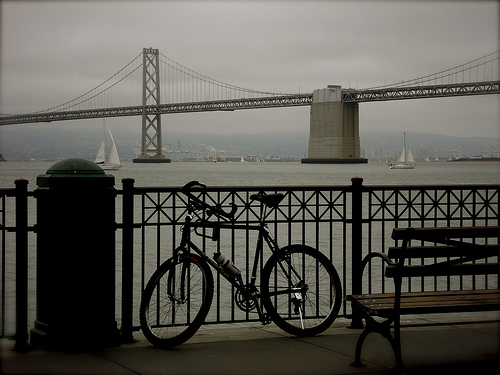<image>
Is there a boat under the bridge? Yes. The boat is positioned underneath the bridge, with the bridge above it in the vertical space. Is there a bridge above the bike? No. The bridge is not positioned above the bike. The vertical arrangement shows a different relationship. 